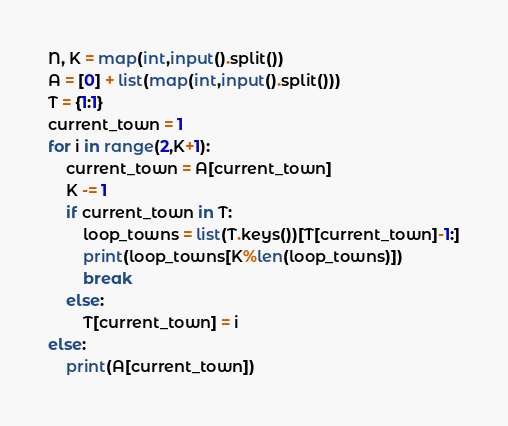<code> <loc_0><loc_0><loc_500><loc_500><_Python_>N, K = map(int,input().split())
A = [0] + list(map(int,input().split()))
T = {1:1}
current_town = 1
for i in range(2,K+1):
    current_town = A[current_town]
    K -= 1
    if current_town in T:
        loop_towns = list(T.keys())[T[current_town]-1:]
        print(loop_towns[K%len(loop_towns)])
        break
    else:
        T[current_town] = i
else:
    print(A[current_town])</code> 